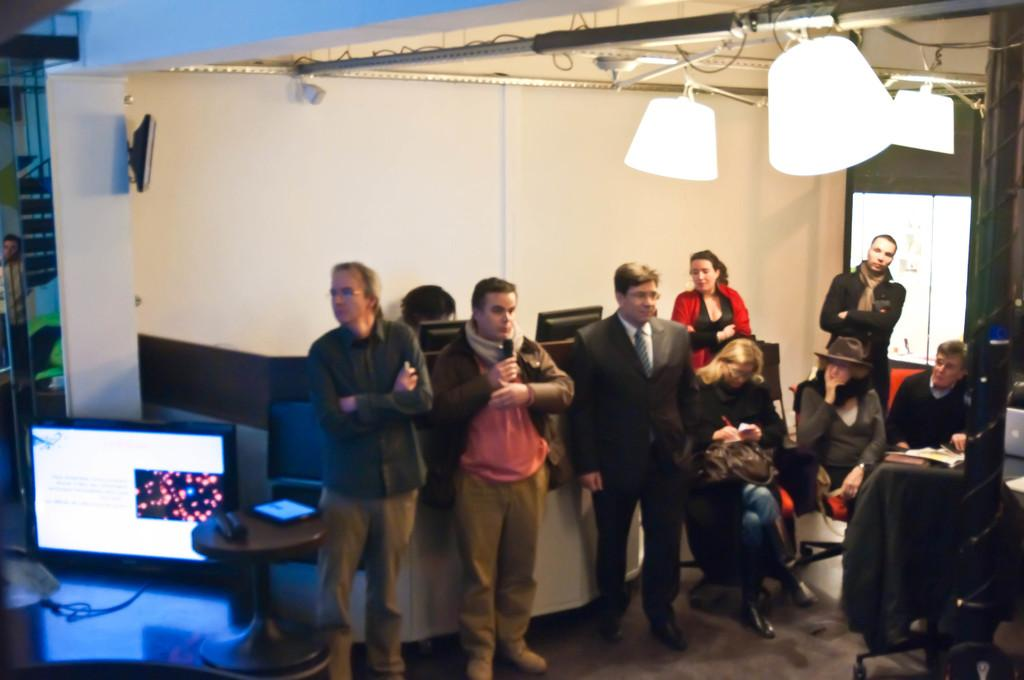What can be seen in the background of the image? There is a wall in the background of the image. Where is the television located in the image? The television is on the ceiling in the image. What are the people in the image doing? There are persons standing on the floor and sitting on chairs in the image. What is the chance of the persons standing on the floor acting in a play in the image? There is no information about a play or acting in the image, so it cannot be determined from the image. Is there any smoke visible in the image? There is no mention of smoke in the provided facts, and therefore no such element can be observed in the image. 